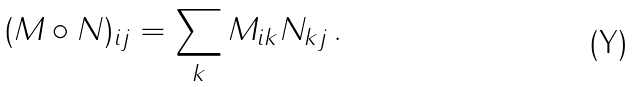<formula> <loc_0><loc_0><loc_500><loc_500>( M \circ N ) _ { i j } = \sum _ { k } M _ { i k } N _ { k j } \, .</formula> 